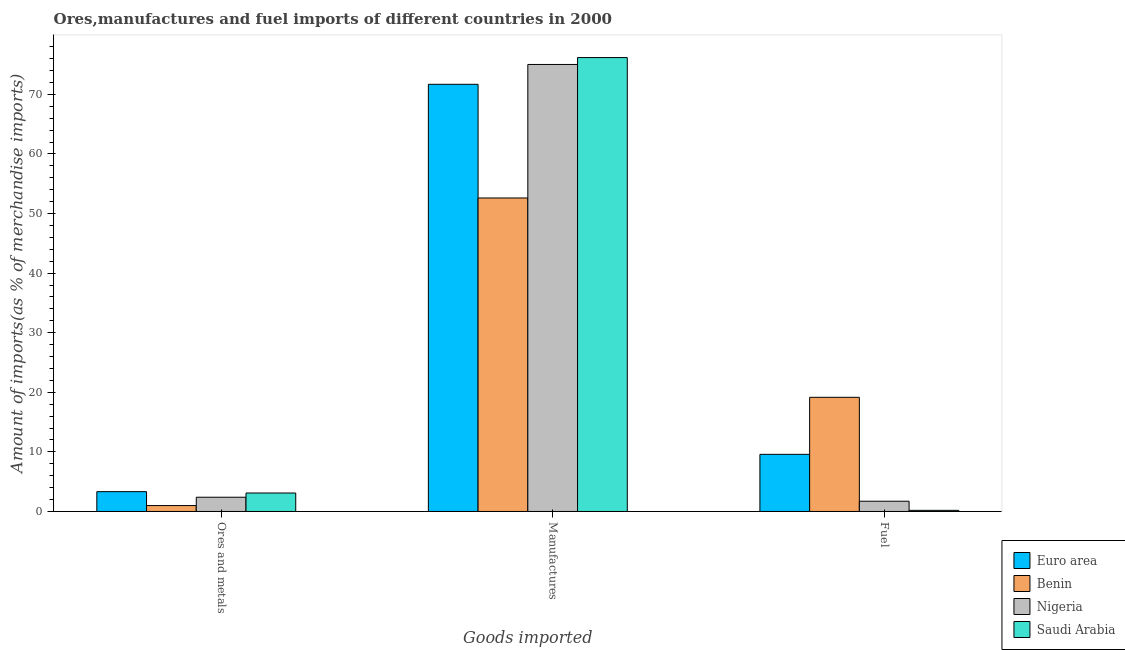Are the number of bars on each tick of the X-axis equal?
Provide a succinct answer. Yes. How many bars are there on the 2nd tick from the left?
Provide a short and direct response. 4. How many bars are there on the 1st tick from the right?
Ensure brevity in your answer.  4. What is the label of the 3rd group of bars from the left?
Your answer should be compact. Fuel. What is the percentage of ores and metals imports in Euro area?
Keep it short and to the point. 3.33. Across all countries, what is the maximum percentage of fuel imports?
Provide a succinct answer. 19.16. Across all countries, what is the minimum percentage of manufactures imports?
Make the answer very short. 52.61. In which country was the percentage of ores and metals imports maximum?
Give a very brief answer. Euro area. In which country was the percentage of fuel imports minimum?
Your response must be concise. Saudi Arabia. What is the total percentage of manufactures imports in the graph?
Provide a short and direct response. 275.5. What is the difference between the percentage of ores and metals imports in Nigeria and that in Saudi Arabia?
Provide a short and direct response. -0.71. What is the difference between the percentage of manufactures imports in Nigeria and the percentage of fuel imports in Benin?
Your answer should be compact. 55.86. What is the average percentage of ores and metals imports per country?
Provide a succinct answer. 2.45. What is the difference between the percentage of manufactures imports and percentage of ores and metals imports in Benin?
Ensure brevity in your answer.  51.62. What is the ratio of the percentage of fuel imports in Benin to that in Saudi Arabia?
Keep it short and to the point. 100.18. What is the difference between the highest and the second highest percentage of fuel imports?
Offer a terse response. 9.57. What is the difference between the highest and the lowest percentage of fuel imports?
Offer a very short reply. 18.97. In how many countries, is the percentage of ores and metals imports greater than the average percentage of ores and metals imports taken over all countries?
Offer a terse response. 2. What does the 3rd bar from the left in Fuel represents?
Keep it short and to the point. Nigeria. What does the 1st bar from the right in Manufactures represents?
Provide a succinct answer. Saudi Arabia. How many bars are there?
Your answer should be very brief. 12. Are all the bars in the graph horizontal?
Your response must be concise. No. What is the difference between two consecutive major ticks on the Y-axis?
Your response must be concise. 10. Does the graph contain any zero values?
Your response must be concise. No. Does the graph contain grids?
Give a very brief answer. No. Where does the legend appear in the graph?
Ensure brevity in your answer.  Bottom right. What is the title of the graph?
Your answer should be compact. Ores,manufactures and fuel imports of different countries in 2000. What is the label or title of the X-axis?
Offer a very short reply. Goods imported. What is the label or title of the Y-axis?
Offer a very short reply. Amount of imports(as % of merchandise imports). What is the Amount of imports(as % of merchandise imports) in Euro area in Ores and metals?
Make the answer very short. 3.33. What is the Amount of imports(as % of merchandise imports) in Benin in Ores and metals?
Your response must be concise. 0.99. What is the Amount of imports(as % of merchandise imports) in Nigeria in Ores and metals?
Give a very brief answer. 2.39. What is the Amount of imports(as % of merchandise imports) in Saudi Arabia in Ores and metals?
Your response must be concise. 3.1. What is the Amount of imports(as % of merchandise imports) of Euro area in Manufactures?
Your answer should be very brief. 71.69. What is the Amount of imports(as % of merchandise imports) of Benin in Manufactures?
Your answer should be very brief. 52.61. What is the Amount of imports(as % of merchandise imports) in Nigeria in Manufactures?
Provide a succinct answer. 75.02. What is the Amount of imports(as % of merchandise imports) of Saudi Arabia in Manufactures?
Your response must be concise. 76.18. What is the Amount of imports(as % of merchandise imports) in Euro area in Fuel?
Provide a short and direct response. 9.59. What is the Amount of imports(as % of merchandise imports) in Benin in Fuel?
Your answer should be compact. 19.16. What is the Amount of imports(as % of merchandise imports) of Nigeria in Fuel?
Your answer should be very brief. 1.72. What is the Amount of imports(as % of merchandise imports) of Saudi Arabia in Fuel?
Make the answer very short. 0.19. Across all Goods imported, what is the maximum Amount of imports(as % of merchandise imports) of Euro area?
Make the answer very short. 71.69. Across all Goods imported, what is the maximum Amount of imports(as % of merchandise imports) in Benin?
Keep it short and to the point. 52.61. Across all Goods imported, what is the maximum Amount of imports(as % of merchandise imports) in Nigeria?
Provide a succinct answer. 75.02. Across all Goods imported, what is the maximum Amount of imports(as % of merchandise imports) of Saudi Arabia?
Offer a terse response. 76.18. Across all Goods imported, what is the minimum Amount of imports(as % of merchandise imports) of Euro area?
Your answer should be very brief. 3.33. Across all Goods imported, what is the minimum Amount of imports(as % of merchandise imports) in Benin?
Keep it short and to the point. 0.99. Across all Goods imported, what is the minimum Amount of imports(as % of merchandise imports) in Nigeria?
Offer a very short reply. 1.72. Across all Goods imported, what is the minimum Amount of imports(as % of merchandise imports) of Saudi Arabia?
Offer a terse response. 0.19. What is the total Amount of imports(as % of merchandise imports) in Euro area in the graph?
Make the answer very short. 84.61. What is the total Amount of imports(as % of merchandise imports) in Benin in the graph?
Your answer should be compact. 72.76. What is the total Amount of imports(as % of merchandise imports) of Nigeria in the graph?
Your answer should be very brief. 79.13. What is the total Amount of imports(as % of merchandise imports) of Saudi Arabia in the graph?
Ensure brevity in your answer.  79.47. What is the difference between the Amount of imports(as % of merchandise imports) of Euro area in Ores and metals and that in Manufactures?
Keep it short and to the point. -68.36. What is the difference between the Amount of imports(as % of merchandise imports) of Benin in Ores and metals and that in Manufactures?
Give a very brief answer. -51.62. What is the difference between the Amount of imports(as % of merchandise imports) of Nigeria in Ores and metals and that in Manufactures?
Provide a succinct answer. -72.63. What is the difference between the Amount of imports(as % of merchandise imports) in Saudi Arabia in Ores and metals and that in Manufactures?
Your answer should be compact. -73.07. What is the difference between the Amount of imports(as % of merchandise imports) of Euro area in Ores and metals and that in Fuel?
Provide a succinct answer. -6.26. What is the difference between the Amount of imports(as % of merchandise imports) in Benin in Ores and metals and that in Fuel?
Your answer should be very brief. -18.17. What is the difference between the Amount of imports(as % of merchandise imports) of Nigeria in Ores and metals and that in Fuel?
Give a very brief answer. 0.67. What is the difference between the Amount of imports(as % of merchandise imports) in Saudi Arabia in Ores and metals and that in Fuel?
Your answer should be compact. 2.91. What is the difference between the Amount of imports(as % of merchandise imports) in Euro area in Manufactures and that in Fuel?
Offer a terse response. 62.1. What is the difference between the Amount of imports(as % of merchandise imports) of Benin in Manufactures and that in Fuel?
Keep it short and to the point. 33.45. What is the difference between the Amount of imports(as % of merchandise imports) in Nigeria in Manufactures and that in Fuel?
Your answer should be very brief. 73.3. What is the difference between the Amount of imports(as % of merchandise imports) in Saudi Arabia in Manufactures and that in Fuel?
Offer a terse response. 75.98. What is the difference between the Amount of imports(as % of merchandise imports) of Euro area in Ores and metals and the Amount of imports(as % of merchandise imports) of Benin in Manufactures?
Your answer should be very brief. -49.29. What is the difference between the Amount of imports(as % of merchandise imports) in Euro area in Ores and metals and the Amount of imports(as % of merchandise imports) in Nigeria in Manufactures?
Offer a very short reply. -71.69. What is the difference between the Amount of imports(as % of merchandise imports) of Euro area in Ores and metals and the Amount of imports(as % of merchandise imports) of Saudi Arabia in Manufactures?
Provide a succinct answer. -72.85. What is the difference between the Amount of imports(as % of merchandise imports) of Benin in Ores and metals and the Amount of imports(as % of merchandise imports) of Nigeria in Manufactures?
Your answer should be very brief. -74.03. What is the difference between the Amount of imports(as % of merchandise imports) in Benin in Ores and metals and the Amount of imports(as % of merchandise imports) in Saudi Arabia in Manufactures?
Your answer should be very brief. -75.18. What is the difference between the Amount of imports(as % of merchandise imports) in Nigeria in Ores and metals and the Amount of imports(as % of merchandise imports) in Saudi Arabia in Manufactures?
Keep it short and to the point. -73.78. What is the difference between the Amount of imports(as % of merchandise imports) of Euro area in Ores and metals and the Amount of imports(as % of merchandise imports) of Benin in Fuel?
Provide a succinct answer. -15.83. What is the difference between the Amount of imports(as % of merchandise imports) in Euro area in Ores and metals and the Amount of imports(as % of merchandise imports) in Nigeria in Fuel?
Provide a succinct answer. 1.6. What is the difference between the Amount of imports(as % of merchandise imports) in Euro area in Ores and metals and the Amount of imports(as % of merchandise imports) in Saudi Arabia in Fuel?
Give a very brief answer. 3.13. What is the difference between the Amount of imports(as % of merchandise imports) in Benin in Ores and metals and the Amount of imports(as % of merchandise imports) in Nigeria in Fuel?
Ensure brevity in your answer.  -0.73. What is the difference between the Amount of imports(as % of merchandise imports) of Benin in Ores and metals and the Amount of imports(as % of merchandise imports) of Saudi Arabia in Fuel?
Keep it short and to the point. 0.8. What is the difference between the Amount of imports(as % of merchandise imports) of Nigeria in Ores and metals and the Amount of imports(as % of merchandise imports) of Saudi Arabia in Fuel?
Provide a short and direct response. 2.2. What is the difference between the Amount of imports(as % of merchandise imports) in Euro area in Manufactures and the Amount of imports(as % of merchandise imports) in Benin in Fuel?
Offer a very short reply. 52.53. What is the difference between the Amount of imports(as % of merchandise imports) of Euro area in Manufactures and the Amount of imports(as % of merchandise imports) of Nigeria in Fuel?
Offer a very short reply. 69.97. What is the difference between the Amount of imports(as % of merchandise imports) of Euro area in Manufactures and the Amount of imports(as % of merchandise imports) of Saudi Arabia in Fuel?
Provide a succinct answer. 71.5. What is the difference between the Amount of imports(as % of merchandise imports) in Benin in Manufactures and the Amount of imports(as % of merchandise imports) in Nigeria in Fuel?
Your answer should be very brief. 50.89. What is the difference between the Amount of imports(as % of merchandise imports) in Benin in Manufactures and the Amount of imports(as % of merchandise imports) in Saudi Arabia in Fuel?
Provide a succinct answer. 52.42. What is the difference between the Amount of imports(as % of merchandise imports) in Nigeria in Manufactures and the Amount of imports(as % of merchandise imports) in Saudi Arabia in Fuel?
Your answer should be compact. 74.83. What is the average Amount of imports(as % of merchandise imports) of Euro area per Goods imported?
Give a very brief answer. 28.2. What is the average Amount of imports(as % of merchandise imports) of Benin per Goods imported?
Your response must be concise. 24.25. What is the average Amount of imports(as % of merchandise imports) of Nigeria per Goods imported?
Ensure brevity in your answer.  26.38. What is the average Amount of imports(as % of merchandise imports) of Saudi Arabia per Goods imported?
Give a very brief answer. 26.49. What is the difference between the Amount of imports(as % of merchandise imports) of Euro area and Amount of imports(as % of merchandise imports) of Benin in Ores and metals?
Your response must be concise. 2.33. What is the difference between the Amount of imports(as % of merchandise imports) of Euro area and Amount of imports(as % of merchandise imports) of Nigeria in Ores and metals?
Ensure brevity in your answer.  0.93. What is the difference between the Amount of imports(as % of merchandise imports) of Euro area and Amount of imports(as % of merchandise imports) of Saudi Arabia in Ores and metals?
Keep it short and to the point. 0.23. What is the difference between the Amount of imports(as % of merchandise imports) in Benin and Amount of imports(as % of merchandise imports) in Nigeria in Ores and metals?
Give a very brief answer. -1.4. What is the difference between the Amount of imports(as % of merchandise imports) of Benin and Amount of imports(as % of merchandise imports) of Saudi Arabia in Ores and metals?
Keep it short and to the point. -2.11. What is the difference between the Amount of imports(as % of merchandise imports) in Nigeria and Amount of imports(as % of merchandise imports) in Saudi Arabia in Ores and metals?
Provide a succinct answer. -0.71. What is the difference between the Amount of imports(as % of merchandise imports) of Euro area and Amount of imports(as % of merchandise imports) of Benin in Manufactures?
Offer a terse response. 19.08. What is the difference between the Amount of imports(as % of merchandise imports) in Euro area and Amount of imports(as % of merchandise imports) in Nigeria in Manufactures?
Give a very brief answer. -3.33. What is the difference between the Amount of imports(as % of merchandise imports) of Euro area and Amount of imports(as % of merchandise imports) of Saudi Arabia in Manufactures?
Your response must be concise. -4.49. What is the difference between the Amount of imports(as % of merchandise imports) of Benin and Amount of imports(as % of merchandise imports) of Nigeria in Manufactures?
Your response must be concise. -22.41. What is the difference between the Amount of imports(as % of merchandise imports) of Benin and Amount of imports(as % of merchandise imports) of Saudi Arabia in Manufactures?
Keep it short and to the point. -23.56. What is the difference between the Amount of imports(as % of merchandise imports) in Nigeria and Amount of imports(as % of merchandise imports) in Saudi Arabia in Manufactures?
Provide a succinct answer. -1.16. What is the difference between the Amount of imports(as % of merchandise imports) of Euro area and Amount of imports(as % of merchandise imports) of Benin in Fuel?
Offer a terse response. -9.57. What is the difference between the Amount of imports(as % of merchandise imports) in Euro area and Amount of imports(as % of merchandise imports) in Nigeria in Fuel?
Your response must be concise. 7.87. What is the difference between the Amount of imports(as % of merchandise imports) of Euro area and Amount of imports(as % of merchandise imports) of Saudi Arabia in Fuel?
Provide a succinct answer. 9.4. What is the difference between the Amount of imports(as % of merchandise imports) in Benin and Amount of imports(as % of merchandise imports) in Nigeria in Fuel?
Keep it short and to the point. 17.44. What is the difference between the Amount of imports(as % of merchandise imports) of Benin and Amount of imports(as % of merchandise imports) of Saudi Arabia in Fuel?
Ensure brevity in your answer.  18.97. What is the difference between the Amount of imports(as % of merchandise imports) of Nigeria and Amount of imports(as % of merchandise imports) of Saudi Arabia in Fuel?
Your answer should be very brief. 1.53. What is the ratio of the Amount of imports(as % of merchandise imports) of Euro area in Ores and metals to that in Manufactures?
Offer a terse response. 0.05. What is the ratio of the Amount of imports(as % of merchandise imports) of Benin in Ores and metals to that in Manufactures?
Keep it short and to the point. 0.02. What is the ratio of the Amount of imports(as % of merchandise imports) of Nigeria in Ores and metals to that in Manufactures?
Your answer should be very brief. 0.03. What is the ratio of the Amount of imports(as % of merchandise imports) in Saudi Arabia in Ores and metals to that in Manufactures?
Ensure brevity in your answer.  0.04. What is the ratio of the Amount of imports(as % of merchandise imports) in Euro area in Ores and metals to that in Fuel?
Keep it short and to the point. 0.35. What is the ratio of the Amount of imports(as % of merchandise imports) in Benin in Ores and metals to that in Fuel?
Your response must be concise. 0.05. What is the ratio of the Amount of imports(as % of merchandise imports) of Nigeria in Ores and metals to that in Fuel?
Provide a succinct answer. 1.39. What is the ratio of the Amount of imports(as % of merchandise imports) in Saudi Arabia in Ores and metals to that in Fuel?
Your response must be concise. 16.21. What is the ratio of the Amount of imports(as % of merchandise imports) of Euro area in Manufactures to that in Fuel?
Your response must be concise. 7.47. What is the ratio of the Amount of imports(as % of merchandise imports) in Benin in Manufactures to that in Fuel?
Provide a succinct answer. 2.75. What is the ratio of the Amount of imports(as % of merchandise imports) in Nigeria in Manufactures to that in Fuel?
Ensure brevity in your answer.  43.58. What is the ratio of the Amount of imports(as % of merchandise imports) in Saudi Arabia in Manufactures to that in Fuel?
Provide a succinct answer. 398.33. What is the difference between the highest and the second highest Amount of imports(as % of merchandise imports) of Euro area?
Make the answer very short. 62.1. What is the difference between the highest and the second highest Amount of imports(as % of merchandise imports) of Benin?
Your answer should be very brief. 33.45. What is the difference between the highest and the second highest Amount of imports(as % of merchandise imports) in Nigeria?
Give a very brief answer. 72.63. What is the difference between the highest and the second highest Amount of imports(as % of merchandise imports) of Saudi Arabia?
Keep it short and to the point. 73.07. What is the difference between the highest and the lowest Amount of imports(as % of merchandise imports) in Euro area?
Offer a terse response. 68.36. What is the difference between the highest and the lowest Amount of imports(as % of merchandise imports) of Benin?
Offer a terse response. 51.62. What is the difference between the highest and the lowest Amount of imports(as % of merchandise imports) of Nigeria?
Give a very brief answer. 73.3. What is the difference between the highest and the lowest Amount of imports(as % of merchandise imports) in Saudi Arabia?
Keep it short and to the point. 75.98. 